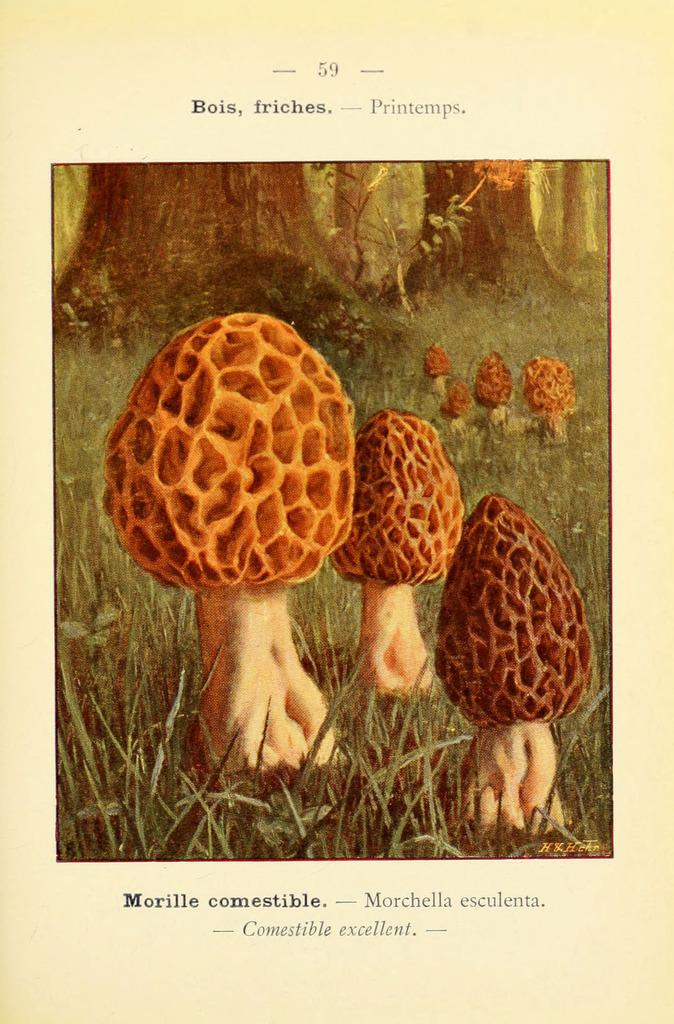What is the main subject of the poster in the image? The poster contains images of mushrooms. What else can be seen on the poster besides the mushroom images? There is text written on the poster. What type of natural environment is depicted in the image? There is a tree trunk and grass in the image, suggesting a forest or park setting. Is there a rat driving a car in the image? No, there is no rat or car present in the image. What type of crime is being committed in the image? There is no crime depicted in the image; it features a poster with mushroom images and text. 